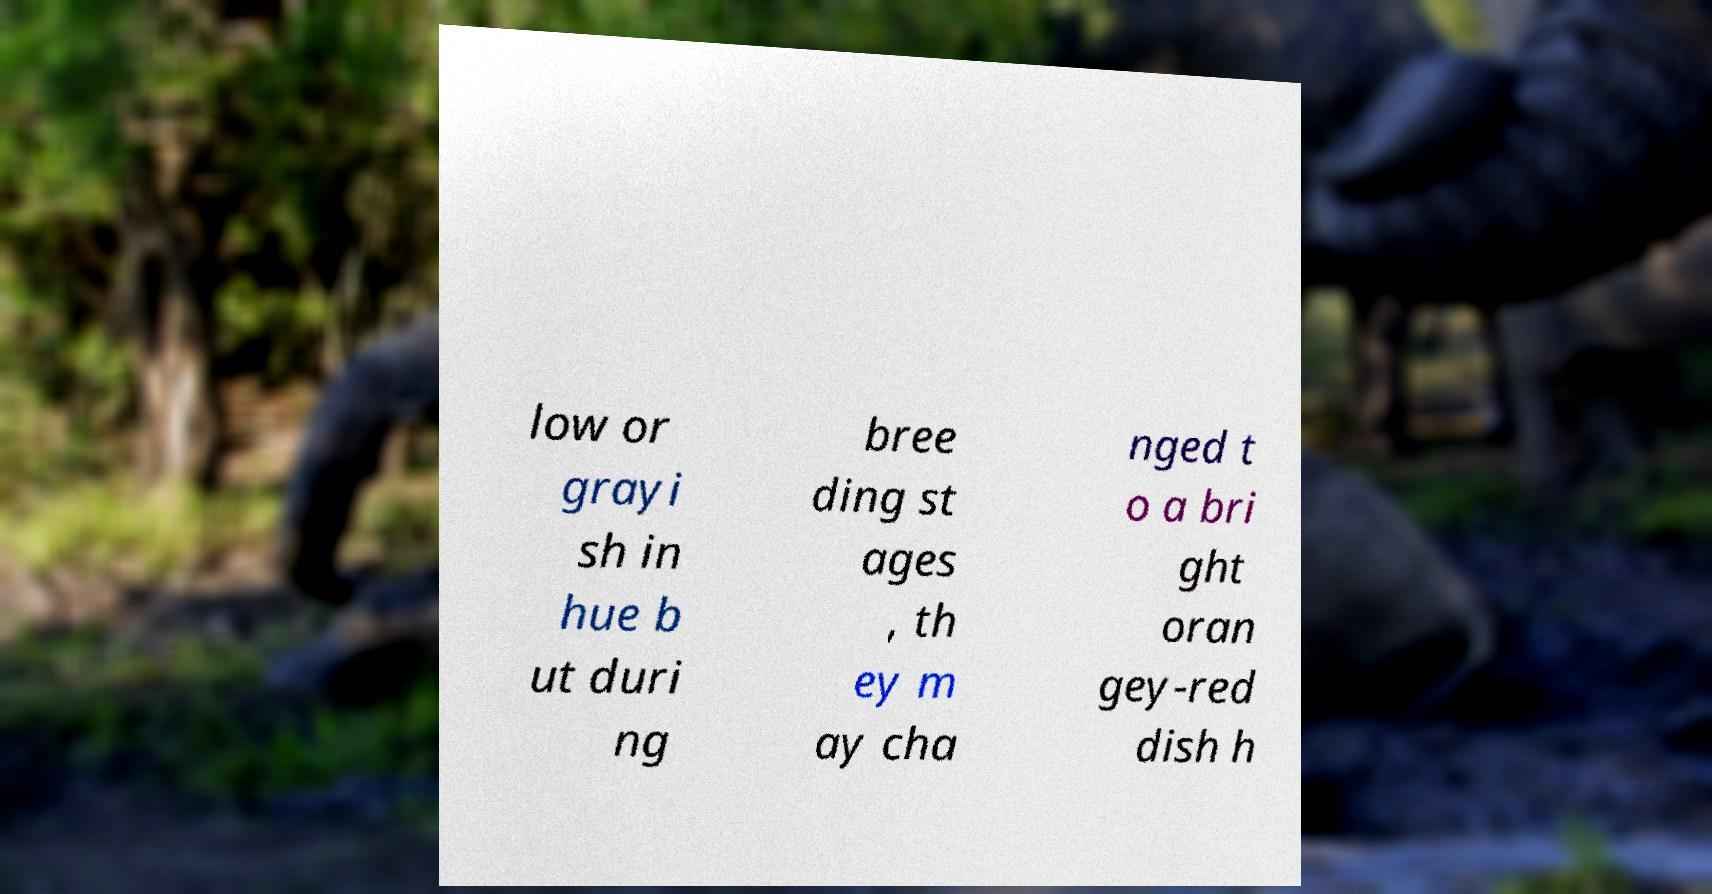For documentation purposes, I need the text within this image transcribed. Could you provide that? low or grayi sh in hue b ut duri ng bree ding st ages , th ey m ay cha nged t o a bri ght oran gey-red dish h 